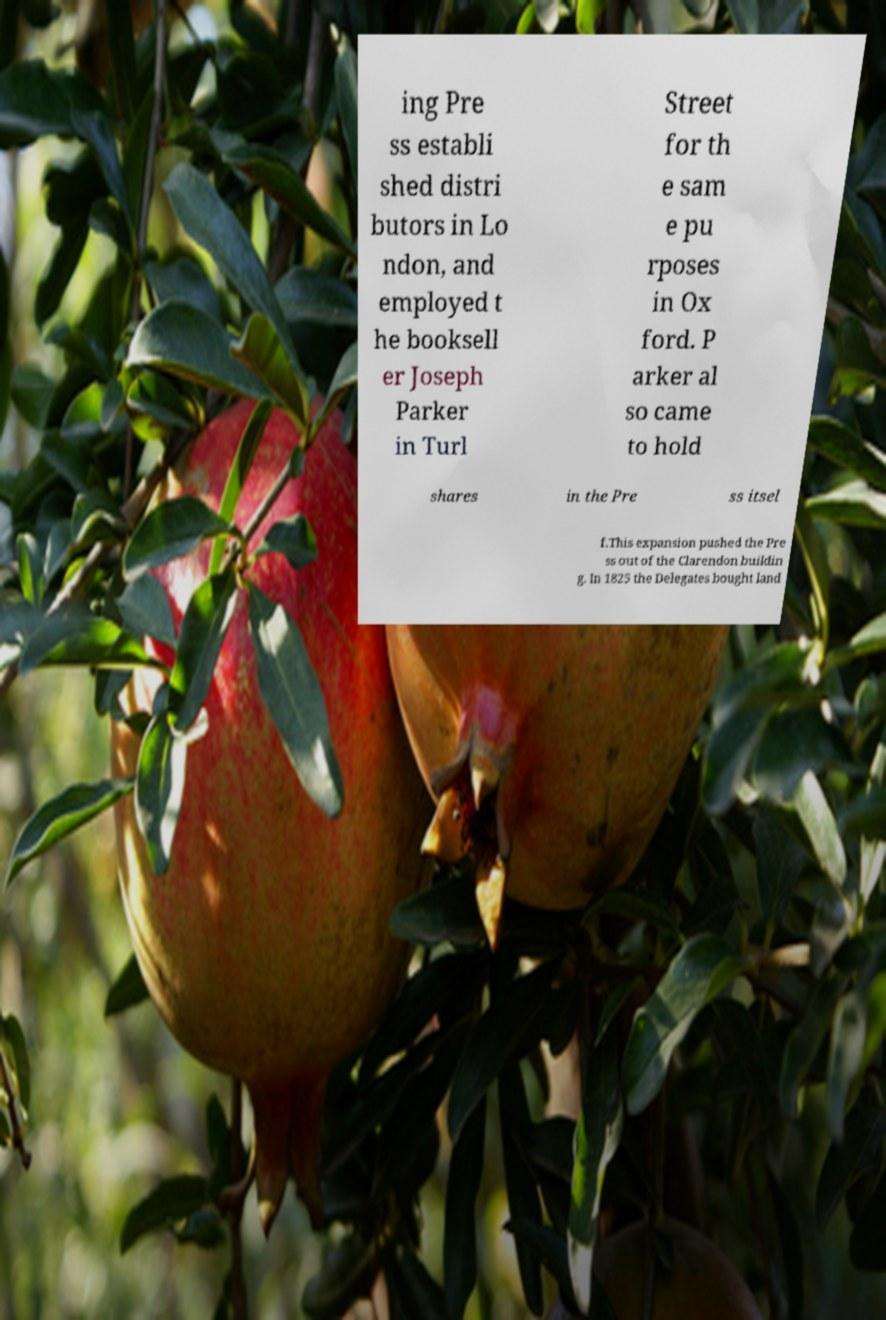I need the written content from this picture converted into text. Can you do that? ing Pre ss establi shed distri butors in Lo ndon, and employed t he booksell er Joseph Parker in Turl Street for th e sam e pu rposes in Ox ford. P arker al so came to hold shares in the Pre ss itsel f.This expansion pushed the Pre ss out of the Clarendon buildin g. In 1825 the Delegates bought land 